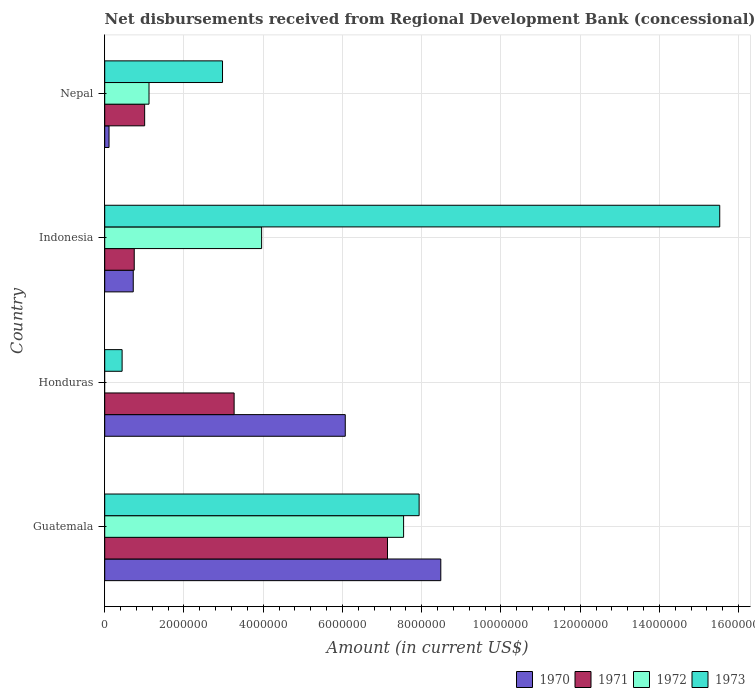How many groups of bars are there?
Ensure brevity in your answer.  4. Are the number of bars per tick equal to the number of legend labels?
Offer a terse response. No. Are the number of bars on each tick of the Y-axis equal?
Provide a short and direct response. No. How many bars are there on the 3rd tick from the bottom?
Offer a terse response. 4. In how many cases, is the number of bars for a given country not equal to the number of legend labels?
Provide a succinct answer. 1. What is the amount of disbursements received from Regional Development Bank in 1970 in Indonesia?
Give a very brief answer. 7.20e+05. Across all countries, what is the maximum amount of disbursements received from Regional Development Bank in 1973?
Your answer should be compact. 1.55e+07. Across all countries, what is the minimum amount of disbursements received from Regional Development Bank in 1972?
Your answer should be very brief. 0. In which country was the amount of disbursements received from Regional Development Bank in 1973 maximum?
Your response must be concise. Indonesia. What is the total amount of disbursements received from Regional Development Bank in 1973 in the graph?
Make the answer very short. 2.69e+07. What is the difference between the amount of disbursements received from Regional Development Bank in 1971 in Honduras and that in Nepal?
Keep it short and to the point. 2.26e+06. What is the difference between the amount of disbursements received from Regional Development Bank in 1972 in Guatemala and the amount of disbursements received from Regional Development Bank in 1971 in Nepal?
Keep it short and to the point. 6.54e+06. What is the average amount of disbursements received from Regional Development Bank in 1970 per country?
Give a very brief answer. 3.85e+06. What is the difference between the amount of disbursements received from Regional Development Bank in 1971 and amount of disbursements received from Regional Development Bank in 1973 in Indonesia?
Ensure brevity in your answer.  -1.48e+07. What is the ratio of the amount of disbursements received from Regional Development Bank in 1973 in Indonesia to that in Nepal?
Ensure brevity in your answer.  5.22. What is the difference between the highest and the second highest amount of disbursements received from Regional Development Bank in 1971?
Give a very brief answer. 3.87e+06. What is the difference between the highest and the lowest amount of disbursements received from Regional Development Bank in 1971?
Your response must be concise. 6.39e+06. In how many countries, is the amount of disbursements received from Regional Development Bank in 1973 greater than the average amount of disbursements received from Regional Development Bank in 1973 taken over all countries?
Your answer should be very brief. 2. Is it the case that in every country, the sum of the amount of disbursements received from Regional Development Bank in 1973 and amount of disbursements received from Regional Development Bank in 1972 is greater than the amount of disbursements received from Regional Development Bank in 1971?
Provide a short and direct response. No. How many countries are there in the graph?
Ensure brevity in your answer.  4. Does the graph contain any zero values?
Your answer should be very brief. Yes. Where does the legend appear in the graph?
Provide a short and direct response. Bottom right. How many legend labels are there?
Offer a terse response. 4. How are the legend labels stacked?
Make the answer very short. Horizontal. What is the title of the graph?
Your response must be concise. Net disbursements received from Regional Development Bank (concessional). Does "2015" appear as one of the legend labels in the graph?
Your response must be concise. No. What is the Amount (in current US$) in 1970 in Guatemala?
Keep it short and to the point. 8.48e+06. What is the Amount (in current US$) in 1971 in Guatemala?
Your response must be concise. 7.14e+06. What is the Amount (in current US$) of 1972 in Guatemala?
Ensure brevity in your answer.  7.54e+06. What is the Amount (in current US$) of 1973 in Guatemala?
Your answer should be compact. 7.94e+06. What is the Amount (in current US$) in 1970 in Honduras?
Make the answer very short. 6.07e+06. What is the Amount (in current US$) in 1971 in Honduras?
Provide a succinct answer. 3.27e+06. What is the Amount (in current US$) in 1972 in Honduras?
Ensure brevity in your answer.  0. What is the Amount (in current US$) in 1973 in Honduras?
Offer a terse response. 4.39e+05. What is the Amount (in current US$) in 1970 in Indonesia?
Ensure brevity in your answer.  7.20e+05. What is the Amount (in current US$) of 1971 in Indonesia?
Your answer should be very brief. 7.45e+05. What is the Amount (in current US$) in 1972 in Indonesia?
Ensure brevity in your answer.  3.96e+06. What is the Amount (in current US$) in 1973 in Indonesia?
Provide a succinct answer. 1.55e+07. What is the Amount (in current US$) of 1970 in Nepal?
Provide a short and direct response. 1.09e+05. What is the Amount (in current US$) in 1971 in Nepal?
Make the answer very short. 1.01e+06. What is the Amount (in current US$) in 1972 in Nepal?
Make the answer very short. 1.12e+06. What is the Amount (in current US$) of 1973 in Nepal?
Keep it short and to the point. 2.97e+06. Across all countries, what is the maximum Amount (in current US$) in 1970?
Ensure brevity in your answer.  8.48e+06. Across all countries, what is the maximum Amount (in current US$) of 1971?
Your answer should be very brief. 7.14e+06. Across all countries, what is the maximum Amount (in current US$) in 1972?
Make the answer very short. 7.54e+06. Across all countries, what is the maximum Amount (in current US$) in 1973?
Give a very brief answer. 1.55e+07. Across all countries, what is the minimum Amount (in current US$) in 1970?
Your answer should be very brief. 1.09e+05. Across all countries, what is the minimum Amount (in current US$) of 1971?
Provide a short and direct response. 7.45e+05. Across all countries, what is the minimum Amount (in current US$) in 1972?
Ensure brevity in your answer.  0. Across all countries, what is the minimum Amount (in current US$) in 1973?
Give a very brief answer. 4.39e+05. What is the total Amount (in current US$) in 1970 in the graph?
Give a very brief answer. 1.54e+07. What is the total Amount (in current US$) of 1971 in the graph?
Offer a terse response. 1.22e+07. What is the total Amount (in current US$) of 1972 in the graph?
Your answer should be compact. 1.26e+07. What is the total Amount (in current US$) of 1973 in the graph?
Offer a terse response. 2.69e+07. What is the difference between the Amount (in current US$) in 1970 in Guatemala and that in Honduras?
Your answer should be very brief. 2.41e+06. What is the difference between the Amount (in current US$) in 1971 in Guatemala and that in Honduras?
Provide a succinct answer. 3.87e+06. What is the difference between the Amount (in current US$) in 1973 in Guatemala and that in Honduras?
Offer a very short reply. 7.50e+06. What is the difference between the Amount (in current US$) of 1970 in Guatemala and that in Indonesia?
Give a very brief answer. 7.76e+06. What is the difference between the Amount (in current US$) in 1971 in Guatemala and that in Indonesia?
Provide a succinct answer. 6.39e+06. What is the difference between the Amount (in current US$) of 1972 in Guatemala and that in Indonesia?
Give a very brief answer. 3.58e+06. What is the difference between the Amount (in current US$) of 1973 in Guatemala and that in Indonesia?
Your answer should be compact. -7.59e+06. What is the difference between the Amount (in current US$) of 1970 in Guatemala and that in Nepal?
Give a very brief answer. 8.37e+06. What is the difference between the Amount (in current US$) in 1971 in Guatemala and that in Nepal?
Make the answer very short. 6.13e+06. What is the difference between the Amount (in current US$) in 1972 in Guatemala and that in Nepal?
Keep it short and to the point. 6.42e+06. What is the difference between the Amount (in current US$) of 1973 in Guatemala and that in Nepal?
Give a very brief answer. 4.96e+06. What is the difference between the Amount (in current US$) in 1970 in Honduras and that in Indonesia?
Your answer should be compact. 5.35e+06. What is the difference between the Amount (in current US$) in 1971 in Honduras and that in Indonesia?
Provide a succinct answer. 2.52e+06. What is the difference between the Amount (in current US$) of 1973 in Honduras and that in Indonesia?
Provide a short and direct response. -1.51e+07. What is the difference between the Amount (in current US$) in 1970 in Honduras and that in Nepal?
Make the answer very short. 5.96e+06. What is the difference between the Amount (in current US$) in 1971 in Honduras and that in Nepal?
Your response must be concise. 2.26e+06. What is the difference between the Amount (in current US$) in 1973 in Honduras and that in Nepal?
Offer a very short reply. -2.53e+06. What is the difference between the Amount (in current US$) in 1970 in Indonesia and that in Nepal?
Your response must be concise. 6.11e+05. What is the difference between the Amount (in current US$) of 1971 in Indonesia and that in Nepal?
Give a very brief answer. -2.63e+05. What is the difference between the Amount (in current US$) in 1972 in Indonesia and that in Nepal?
Give a very brief answer. 2.84e+06. What is the difference between the Amount (in current US$) of 1973 in Indonesia and that in Nepal?
Make the answer very short. 1.25e+07. What is the difference between the Amount (in current US$) in 1970 in Guatemala and the Amount (in current US$) in 1971 in Honduras?
Your response must be concise. 5.22e+06. What is the difference between the Amount (in current US$) of 1970 in Guatemala and the Amount (in current US$) of 1973 in Honduras?
Your answer should be compact. 8.04e+06. What is the difference between the Amount (in current US$) of 1971 in Guatemala and the Amount (in current US$) of 1973 in Honduras?
Your answer should be compact. 6.70e+06. What is the difference between the Amount (in current US$) in 1972 in Guatemala and the Amount (in current US$) in 1973 in Honduras?
Offer a terse response. 7.10e+06. What is the difference between the Amount (in current US$) of 1970 in Guatemala and the Amount (in current US$) of 1971 in Indonesia?
Your answer should be compact. 7.74e+06. What is the difference between the Amount (in current US$) of 1970 in Guatemala and the Amount (in current US$) of 1972 in Indonesia?
Give a very brief answer. 4.52e+06. What is the difference between the Amount (in current US$) of 1970 in Guatemala and the Amount (in current US$) of 1973 in Indonesia?
Give a very brief answer. -7.04e+06. What is the difference between the Amount (in current US$) in 1971 in Guatemala and the Amount (in current US$) in 1972 in Indonesia?
Ensure brevity in your answer.  3.18e+06. What is the difference between the Amount (in current US$) of 1971 in Guatemala and the Amount (in current US$) of 1973 in Indonesia?
Provide a short and direct response. -8.38e+06. What is the difference between the Amount (in current US$) of 1972 in Guatemala and the Amount (in current US$) of 1973 in Indonesia?
Provide a short and direct response. -7.98e+06. What is the difference between the Amount (in current US$) of 1970 in Guatemala and the Amount (in current US$) of 1971 in Nepal?
Make the answer very short. 7.47e+06. What is the difference between the Amount (in current US$) of 1970 in Guatemala and the Amount (in current US$) of 1972 in Nepal?
Provide a succinct answer. 7.36e+06. What is the difference between the Amount (in current US$) in 1970 in Guatemala and the Amount (in current US$) in 1973 in Nepal?
Keep it short and to the point. 5.51e+06. What is the difference between the Amount (in current US$) of 1971 in Guatemala and the Amount (in current US$) of 1972 in Nepal?
Your answer should be compact. 6.02e+06. What is the difference between the Amount (in current US$) of 1971 in Guatemala and the Amount (in current US$) of 1973 in Nepal?
Give a very brief answer. 4.16e+06. What is the difference between the Amount (in current US$) of 1972 in Guatemala and the Amount (in current US$) of 1973 in Nepal?
Your answer should be compact. 4.57e+06. What is the difference between the Amount (in current US$) of 1970 in Honduras and the Amount (in current US$) of 1971 in Indonesia?
Provide a short and direct response. 5.33e+06. What is the difference between the Amount (in current US$) in 1970 in Honduras and the Amount (in current US$) in 1972 in Indonesia?
Give a very brief answer. 2.11e+06. What is the difference between the Amount (in current US$) of 1970 in Honduras and the Amount (in current US$) of 1973 in Indonesia?
Your answer should be very brief. -9.45e+06. What is the difference between the Amount (in current US$) of 1971 in Honduras and the Amount (in current US$) of 1972 in Indonesia?
Offer a terse response. -6.94e+05. What is the difference between the Amount (in current US$) in 1971 in Honduras and the Amount (in current US$) in 1973 in Indonesia?
Your response must be concise. -1.23e+07. What is the difference between the Amount (in current US$) in 1970 in Honduras and the Amount (in current US$) in 1971 in Nepal?
Make the answer very short. 5.06e+06. What is the difference between the Amount (in current US$) of 1970 in Honduras and the Amount (in current US$) of 1972 in Nepal?
Offer a very short reply. 4.95e+06. What is the difference between the Amount (in current US$) of 1970 in Honduras and the Amount (in current US$) of 1973 in Nepal?
Offer a very short reply. 3.10e+06. What is the difference between the Amount (in current US$) of 1971 in Honduras and the Amount (in current US$) of 1972 in Nepal?
Give a very brief answer. 2.15e+06. What is the difference between the Amount (in current US$) of 1971 in Honduras and the Amount (in current US$) of 1973 in Nepal?
Keep it short and to the point. 2.93e+05. What is the difference between the Amount (in current US$) in 1970 in Indonesia and the Amount (in current US$) in 1971 in Nepal?
Provide a succinct answer. -2.88e+05. What is the difference between the Amount (in current US$) of 1970 in Indonesia and the Amount (in current US$) of 1972 in Nepal?
Your answer should be very brief. -3.98e+05. What is the difference between the Amount (in current US$) in 1970 in Indonesia and the Amount (in current US$) in 1973 in Nepal?
Offer a terse response. -2.25e+06. What is the difference between the Amount (in current US$) in 1971 in Indonesia and the Amount (in current US$) in 1972 in Nepal?
Provide a short and direct response. -3.73e+05. What is the difference between the Amount (in current US$) in 1971 in Indonesia and the Amount (in current US$) in 1973 in Nepal?
Provide a short and direct response. -2.23e+06. What is the difference between the Amount (in current US$) in 1972 in Indonesia and the Amount (in current US$) in 1973 in Nepal?
Ensure brevity in your answer.  9.87e+05. What is the average Amount (in current US$) of 1970 per country?
Your answer should be compact. 3.85e+06. What is the average Amount (in current US$) of 1971 per country?
Give a very brief answer. 3.04e+06. What is the average Amount (in current US$) of 1972 per country?
Your response must be concise. 3.16e+06. What is the average Amount (in current US$) in 1973 per country?
Offer a terse response. 6.72e+06. What is the difference between the Amount (in current US$) in 1970 and Amount (in current US$) in 1971 in Guatemala?
Offer a very short reply. 1.34e+06. What is the difference between the Amount (in current US$) of 1970 and Amount (in current US$) of 1972 in Guatemala?
Your response must be concise. 9.39e+05. What is the difference between the Amount (in current US$) in 1970 and Amount (in current US$) in 1973 in Guatemala?
Give a very brief answer. 5.47e+05. What is the difference between the Amount (in current US$) in 1971 and Amount (in current US$) in 1972 in Guatemala?
Your answer should be compact. -4.06e+05. What is the difference between the Amount (in current US$) of 1971 and Amount (in current US$) of 1973 in Guatemala?
Make the answer very short. -7.98e+05. What is the difference between the Amount (in current US$) in 1972 and Amount (in current US$) in 1973 in Guatemala?
Offer a very short reply. -3.92e+05. What is the difference between the Amount (in current US$) of 1970 and Amount (in current US$) of 1971 in Honduras?
Provide a succinct answer. 2.80e+06. What is the difference between the Amount (in current US$) of 1970 and Amount (in current US$) of 1973 in Honduras?
Your answer should be very brief. 5.63e+06. What is the difference between the Amount (in current US$) in 1971 and Amount (in current US$) in 1973 in Honduras?
Ensure brevity in your answer.  2.83e+06. What is the difference between the Amount (in current US$) in 1970 and Amount (in current US$) in 1971 in Indonesia?
Your answer should be compact. -2.50e+04. What is the difference between the Amount (in current US$) in 1970 and Amount (in current US$) in 1972 in Indonesia?
Your response must be concise. -3.24e+06. What is the difference between the Amount (in current US$) in 1970 and Amount (in current US$) in 1973 in Indonesia?
Offer a terse response. -1.48e+07. What is the difference between the Amount (in current US$) in 1971 and Amount (in current US$) in 1972 in Indonesia?
Keep it short and to the point. -3.22e+06. What is the difference between the Amount (in current US$) of 1971 and Amount (in current US$) of 1973 in Indonesia?
Make the answer very short. -1.48e+07. What is the difference between the Amount (in current US$) of 1972 and Amount (in current US$) of 1973 in Indonesia?
Provide a succinct answer. -1.16e+07. What is the difference between the Amount (in current US$) of 1970 and Amount (in current US$) of 1971 in Nepal?
Your answer should be compact. -8.99e+05. What is the difference between the Amount (in current US$) of 1970 and Amount (in current US$) of 1972 in Nepal?
Provide a succinct answer. -1.01e+06. What is the difference between the Amount (in current US$) in 1970 and Amount (in current US$) in 1973 in Nepal?
Ensure brevity in your answer.  -2.86e+06. What is the difference between the Amount (in current US$) in 1971 and Amount (in current US$) in 1972 in Nepal?
Your answer should be very brief. -1.10e+05. What is the difference between the Amount (in current US$) of 1971 and Amount (in current US$) of 1973 in Nepal?
Keep it short and to the point. -1.96e+06. What is the difference between the Amount (in current US$) in 1972 and Amount (in current US$) in 1973 in Nepal?
Provide a short and direct response. -1.86e+06. What is the ratio of the Amount (in current US$) of 1970 in Guatemala to that in Honduras?
Your answer should be very brief. 1.4. What is the ratio of the Amount (in current US$) of 1971 in Guatemala to that in Honduras?
Ensure brevity in your answer.  2.19. What is the ratio of the Amount (in current US$) of 1973 in Guatemala to that in Honduras?
Keep it short and to the point. 18.08. What is the ratio of the Amount (in current US$) of 1970 in Guatemala to that in Indonesia?
Provide a succinct answer. 11.78. What is the ratio of the Amount (in current US$) in 1971 in Guatemala to that in Indonesia?
Offer a very short reply. 9.58. What is the ratio of the Amount (in current US$) in 1972 in Guatemala to that in Indonesia?
Keep it short and to the point. 1.9. What is the ratio of the Amount (in current US$) of 1973 in Guatemala to that in Indonesia?
Provide a short and direct response. 0.51. What is the ratio of the Amount (in current US$) of 1970 in Guatemala to that in Nepal?
Offer a very short reply. 77.82. What is the ratio of the Amount (in current US$) of 1971 in Guatemala to that in Nepal?
Provide a succinct answer. 7.08. What is the ratio of the Amount (in current US$) of 1972 in Guatemala to that in Nepal?
Give a very brief answer. 6.75. What is the ratio of the Amount (in current US$) of 1973 in Guatemala to that in Nepal?
Offer a very short reply. 2.67. What is the ratio of the Amount (in current US$) of 1970 in Honduras to that in Indonesia?
Ensure brevity in your answer.  8.43. What is the ratio of the Amount (in current US$) of 1971 in Honduras to that in Indonesia?
Keep it short and to the point. 4.38. What is the ratio of the Amount (in current US$) in 1973 in Honduras to that in Indonesia?
Give a very brief answer. 0.03. What is the ratio of the Amount (in current US$) in 1970 in Honduras to that in Nepal?
Keep it short and to the point. 55.7. What is the ratio of the Amount (in current US$) of 1971 in Honduras to that in Nepal?
Your response must be concise. 3.24. What is the ratio of the Amount (in current US$) of 1973 in Honduras to that in Nepal?
Offer a terse response. 0.15. What is the ratio of the Amount (in current US$) in 1970 in Indonesia to that in Nepal?
Your answer should be compact. 6.61. What is the ratio of the Amount (in current US$) of 1971 in Indonesia to that in Nepal?
Keep it short and to the point. 0.74. What is the ratio of the Amount (in current US$) in 1972 in Indonesia to that in Nepal?
Provide a succinct answer. 3.54. What is the ratio of the Amount (in current US$) of 1973 in Indonesia to that in Nepal?
Offer a very short reply. 5.22. What is the difference between the highest and the second highest Amount (in current US$) of 1970?
Keep it short and to the point. 2.41e+06. What is the difference between the highest and the second highest Amount (in current US$) in 1971?
Your answer should be very brief. 3.87e+06. What is the difference between the highest and the second highest Amount (in current US$) of 1972?
Your answer should be compact. 3.58e+06. What is the difference between the highest and the second highest Amount (in current US$) of 1973?
Provide a succinct answer. 7.59e+06. What is the difference between the highest and the lowest Amount (in current US$) in 1970?
Make the answer very short. 8.37e+06. What is the difference between the highest and the lowest Amount (in current US$) in 1971?
Keep it short and to the point. 6.39e+06. What is the difference between the highest and the lowest Amount (in current US$) in 1972?
Provide a succinct answer. 7.54e+06. What is the difference between the highest and the lowest Amount (in current US$) of 1973?
Provide a short and direct response. 1.51e+07. 